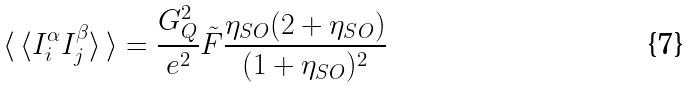Convert formula to latex. <formula><loc_0><loc_0><loc_500><loc_500>\langle \, \langle I ^ { \alpha } _ { i } I ^ { \beta } _ { j } \rangle \, \rangle = \frac { G _ { Q } ^ { 2 } } { e ^ { 2 } } \tilde { F } \frac { \eta _ { S O } ( 2 + \eta _ { S O } ) } { ( 1 + \eta _ { S O } ) ^ { 2 } }</formula> 